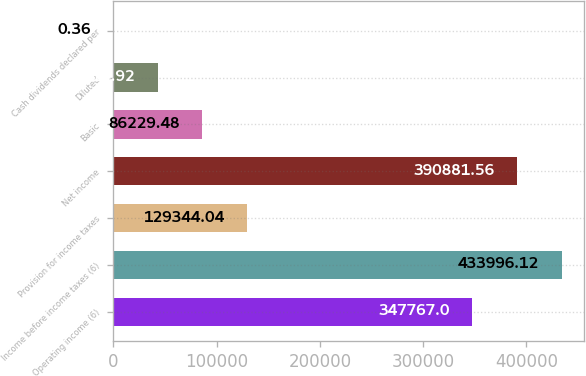<chart> <loc_0><loc_0><loc_500><loc_500><bar_chart><fcel>Operating income (6)<fcel>Income before income taxes (6)<fcel>Provision for income taxes<fcel>Net income<fcel>Basic<fcel>Diluted<fcel>Cash dividends declared per<nl><fcel>347767<fcel>433996<fcel>129344<fcel>390882<fcel>86229.5<fcel>43114.9<fcel>0.36<nl></chart> 